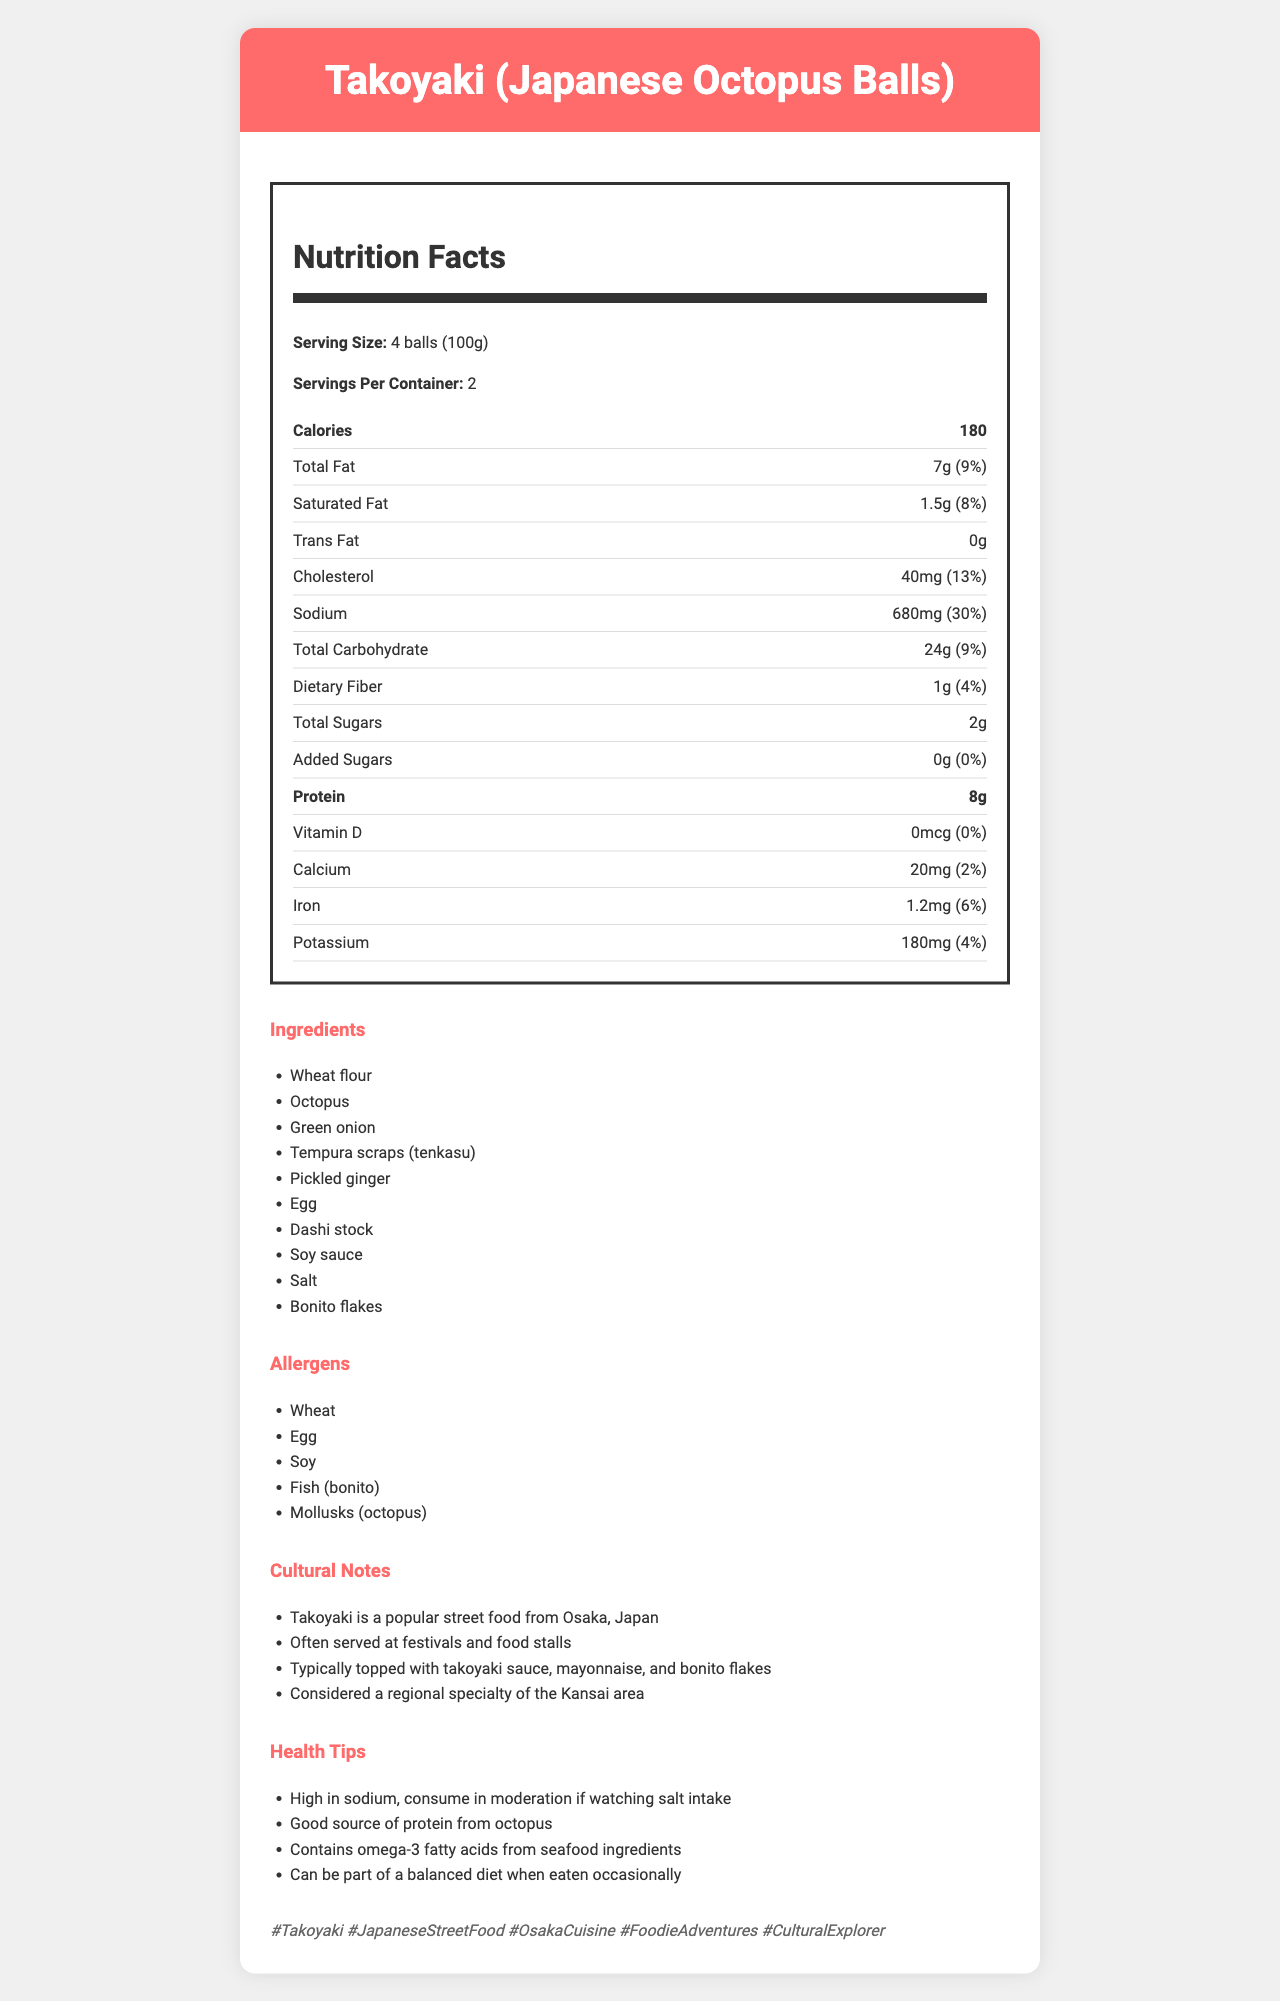what is the serving size for Takoyaki? The document mentions the serving size for Takoyaki as "4 balls (100g)" in the nutrition facts section.
Answer: 4 balls (100g) How many servings are there per container? The document states that there are 2 servings per container in the nutrition facts section.
Answer: 2 How many calories are there in one serving of Takoyaki? The nutrition facts section lists 180 calories per serving.
Answer: 180 What percentage of the daily value for sodium does one serving of Takoyaki provide? The nutrition facts section shows that one serving of Takoyaki provides 30% of the daily value for sodium.
Answer: 30% How much total fat is in one serving of Takoyaki? The nutrition facts section specifies that there are 7g of total fat in one serving.
Answer: 7g Which of the following ingredients is NOT listed in the document for Takoyaki? A. Octopus B. Green onion C. Cheese D. Dashi stock The list of ingredients includes Octopus, Green onion, and Dashi stock, but not Cheese.
Answer: C. Cheese How much protein is in each serving of Takoyaki? The nutrition facts section indicates that each serving contains 8g of protein.
Answer: 8g What are the allergens listed in the document for Takoyaki? A. Wheat B. Egg C. Soy D. All of the above The allergens section lists Wheat, Egg, Soy, Fish (bonito), and Mollusks (octopus).
Answer: D. All of the above Does Takoyaki have any trans fat? The nutrition facts section shows 0g of trans fat.
Answer: No Summarize the main idea of the document. The document outlines the nutritional content, ingredients, and allergen information of Takoyaki, along with cultural insights, health tips, and relevant social media hashtags, offering a comprehensive overview of the dish.
Answer: The document provides detailed nutritional information, ingredients, allergens, cultural notes, health tips, and social media hashtags for Takoyaki, a popular Japanese street food. How many grams of dietary fiber are in one serving of Takoyaki? The nutrition facts section states that there is 1g of dietary fiber in one serving.
Answer: 1g What is the daily value percentage for saturated fat in one serving of Takoyaki? The document mentions that one serving contains 8% of the daily value for saturated fat.
Answer: 8% What is the vitamin D content in one serving of Takoyaki? The nutrition facts section indicates that there is 0mcg of vitamin D per serving.
Answer: 0mcg Which of the following hashtags is NOT suggested for social media posts about Takoyaki? A. #Takoyaki B. #JapaneseStreetFood C. #HealthyEating D. #OsakaCuisine The suggested hashtags in the document include #Takoyaki, #JapaneseStreetFood, #OsakaCuisine, but not #HealthyEating.
Answer: C. #HealthyEating Are there any added sugars in one serving of Takoyaki? The document indicates that there are 0g of added sugars in one serving of Takoyaki.
Answer: No What kind of special occasions is Takoyaki commonly associated with? The cultural notes mention that Takoyaki is often served at festivals and food stalls.
Answer: Festivals and food stalls Is the exact recipe for Takoyaki provided in the document? The document lists ingredients but does not provide detailed recipe instructions.
Answer: Not enough information 